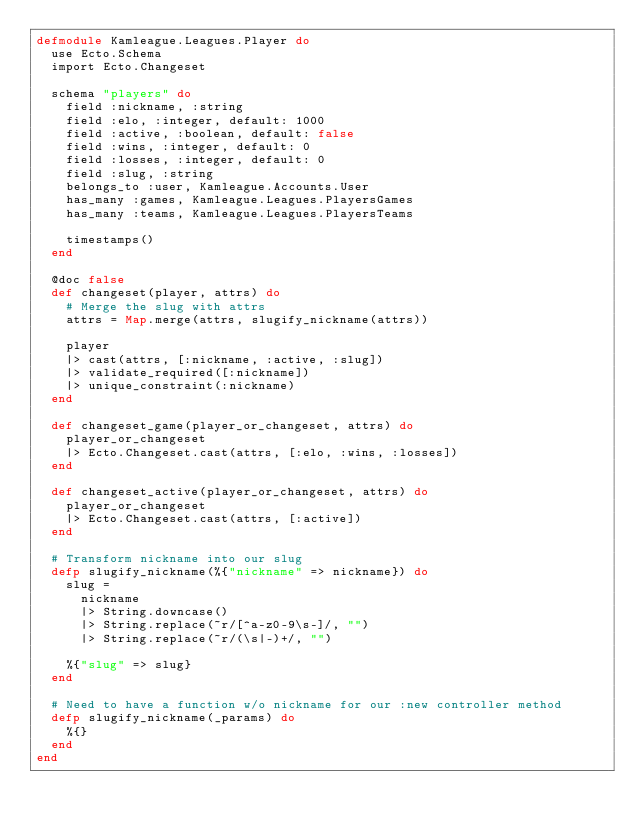<code> <loc_0><loc_0><loc_500><loc_500><_Elixir_>defmodule Kamleague.Leagues.Player do
  use Ecto.Schema
  import Ecto.Changeset

  schema "players" do
    field :nickname, :string
    field :elo, :integer, default: 1000
    field :active, :boolean, default: false
    field :wins, :integer, default: 0
    field :losses, :integer, default: 0
    field :slug, :string
    belongs_to :user, Kamleague.Accounts.User
    has_many :games, Kamleague.Leagues.PlayersGames
    has_many :teams, Kamleague.Leagues.PlayersTeams

    timestamps()
  end

  @doc false
  def changeset(player, attrs) do
    # Merge the slug with attrs
    attrs = Map.merge(attrs, slugify_nickname(attrs))

    player
    |> cast(attrs, [:nickname, :active, :slug])
    |> validate_required([:nickname])
    |> unique_constraint(:nickname)
  end

  def changeset_game(player_or_changeset, attrs) do
    player_or_changeset
    |> Ecto.Changeset.cast(attrs, [:elo, :wins, :losses])
  end

  def changeset_active(player_or_changeset, attrs) do
    player_or_changeset
    |> Ecto.Changeset.cast(attrs, [:active])
  end

  # Transform nickname into our slug
  defp slugify_nickname(%{"nickname" => nickname}) do
    slug =
      nickname
      |> String.downcase()
      |> String.replace(~r/[^a-z0-9\s-]/, "")
      |> String.replace(~r/(\s|-)+/, "")

    %{"slug" => slug}
  end

  # Need to have a function w/o nickname for our :new controller method
  defp slugify_nickname(_params) do
    %{}
  end
end
</code> 